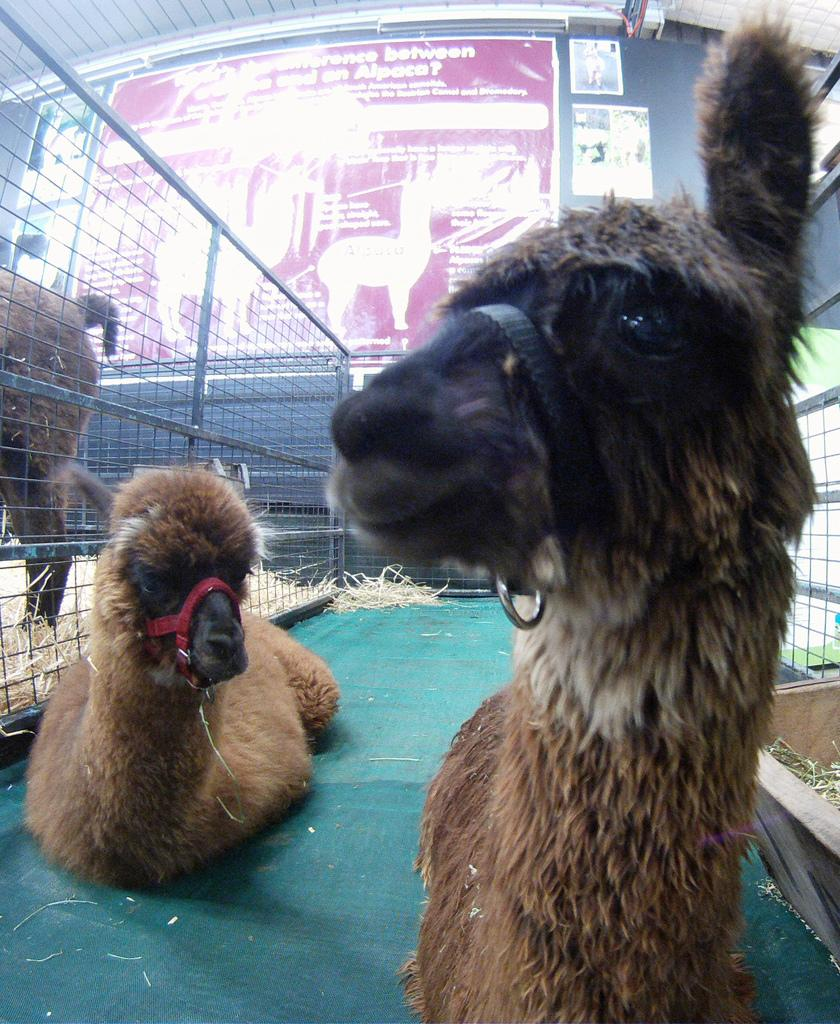What type of living organisms can be seen in the image? There are animals in the image. What is the primary element that separates the animals from their surroundings? There is a fence in the image. What can be seen on the wall in the background of the image? There are boards placed on a wall in the background of the image. What type of brake system can be seen on the animals in the image? There is no brake system present on the animals in the image. What type of drug is being administered to the animals in the image? There is no drug being administered to the animals in the image. 